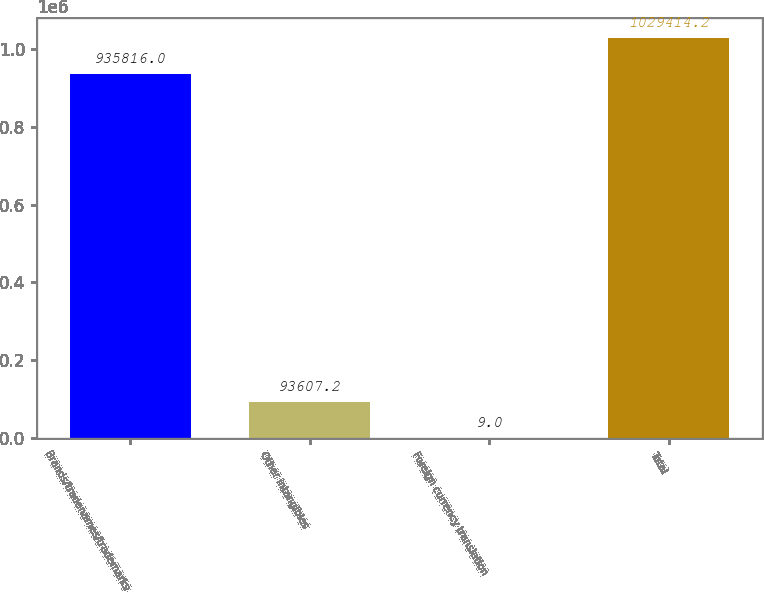Convert chart to OTSL. <chart><loc_0><loc_0><loc_500><loc_500><bar_chart><fcel>Brands/tradenames/trademarks<fcel>Other intangibles<fcel>Foreign currency translation<fcel>Total<nl><fcel>935816<fcel>93607.2<fcel>9<fcel>1.02941e+06<nl></chart> 